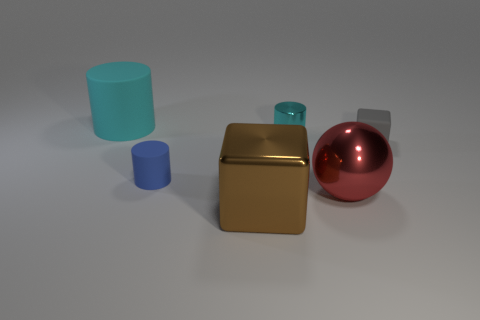Subtract all blue cylinders. How many cylinders are left? 2 Subtract all cyan cylinders. How many cylinders are left? 1 Add 2 big brown metallic objects. How many objects exist? 8 Subtract all cubes. How many objects are left? 4 Subtract 2 blocks. How many blocks are left? 0 Subtract all blue cubes. Subtract all purple cylinders. How many cubes are left? 2 Subtract all blue balls. How many cyan cylinders are left? 2 Subtract all large purple spheres. Subtract all large rubber cylinders. How many objects are left? 5 Add 3 red metallic balls. How many red metallic balls are left? 4 Add 6 large brown things. How many large brown things exist? 7 